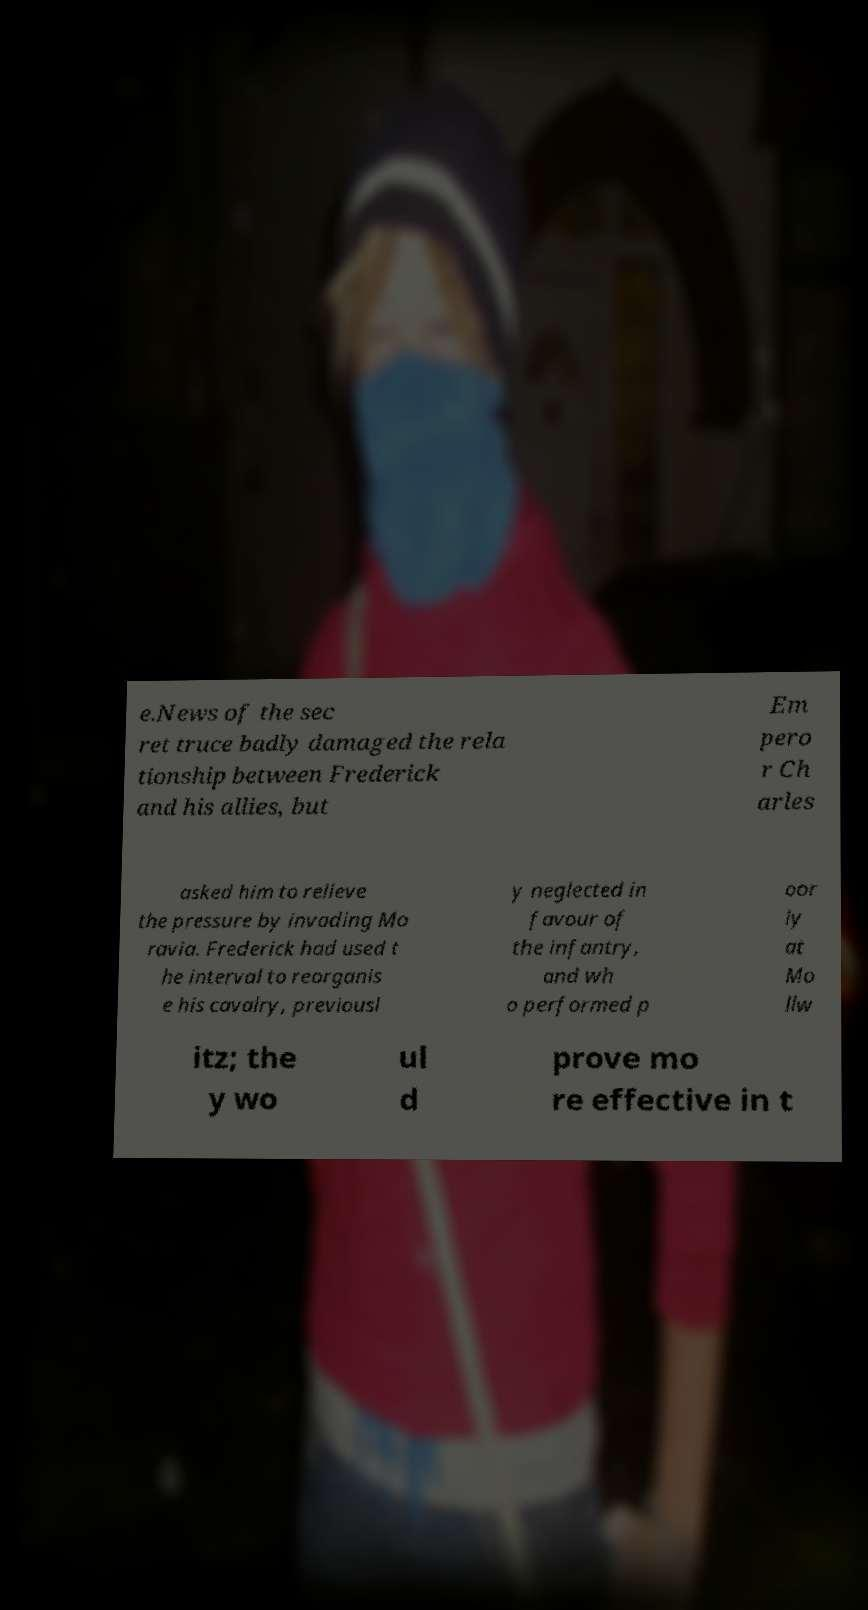Could you extract and type out the text from this image? e.News of the sec ret truce badly damaged the rela tionship between Frederick and his allies, but Em pero r Ch arles asked him to relieve the pressure by invading Mo ravia. Frederick had used t he interval to reorganis e his cavalry, previousl y neglected in favour of the infantry, and wh o performed p oor ly at Mo llw itz; the y wo ul d prove mo re effective in t 